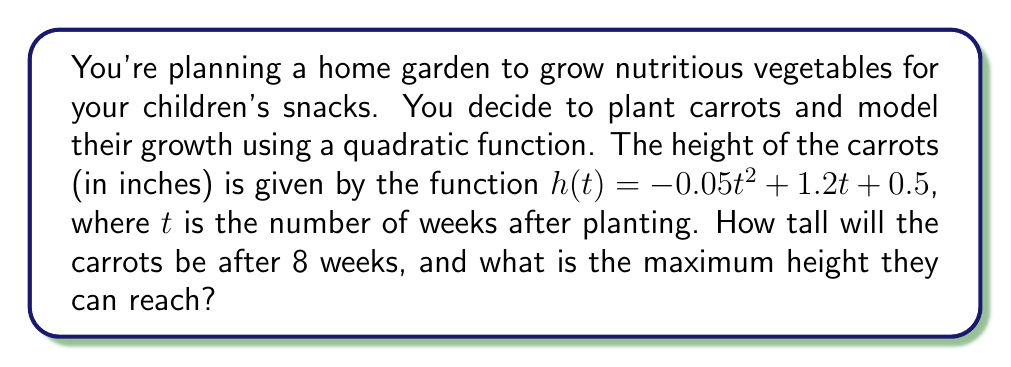Could you help me with this problem? To solve this problem, we'll follow these steps:

1. Calculate the height of the carrots after 8 weeks:
   Substitute $t = 8$ into the given function:
   $$h(8) = -0.05(8)^2 + 1.2(8) + 0.5$$
   $$= -0.05(64) + 9.6 + 0.5$$
   $$= -3.2 + 9.6 + 0.5$$
   $$= 6.9$$

2. Find the maximum height:
   For a quadratic function in the form $f(x) = ax^2 + bx + c$, the maximum (or minimum) occurs at $x = -\frac{b}{2a}$.
   
   In our case, $a = -0.05$, $b = 1.2$, and $c = 0.5$.
   
   The time at which the maximum height occurs is:
   $$t_{max} = -\frac{b}{2a} = -\frac{1.2}{2(-0.05)} = 12$$

   To find the maximum height, substitute $t = 12$ into the original function:
   $$h(12) = -0.05(12)^2 + 1.2(12) + 0.5$$
   $$= -0.05(144) + 14.4 + 0.5$$
   $$= -7.2 + 14.4 + 0.5$$
   $$= 7.7$$

Therefore, the carrots will be 6.9 inches tall after 8 weeks, and their maximum height is 7.7 inches.
Answer: After 8 weeks, the carrots will be 6.9 inches tall. The maximum height they can reach is 7.7 inches. 